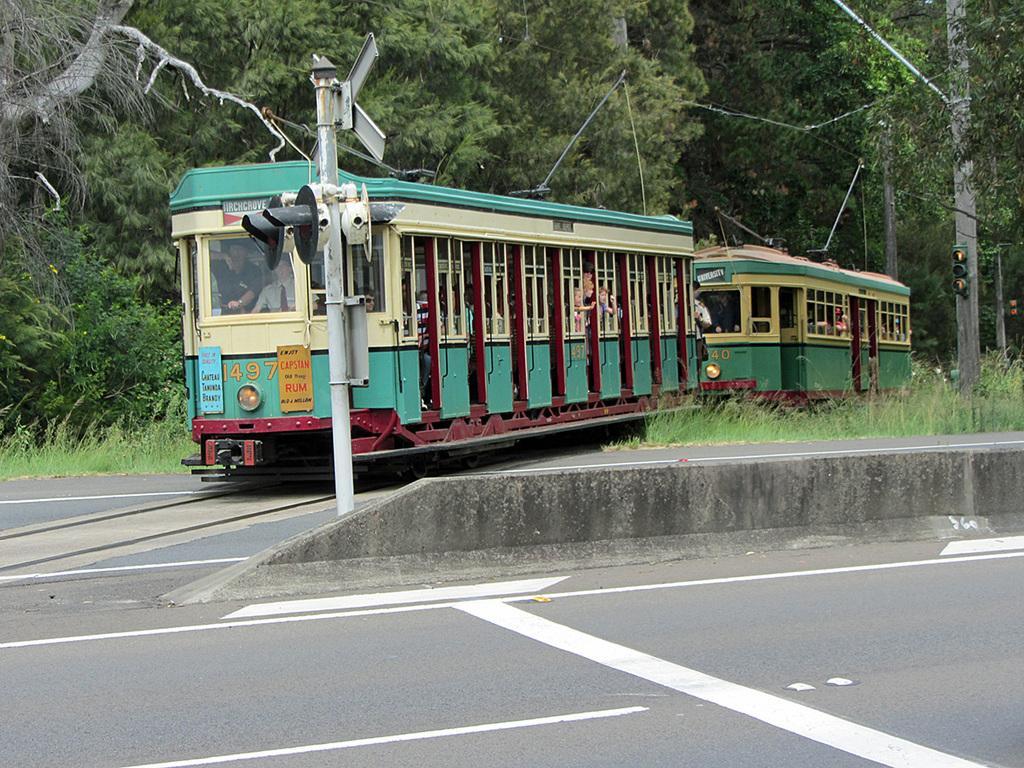Could you give a brief overview of what you see in this image? This is an outside view. In the middle of the image I can see the vehicles on the road. Inside the vehicles, I can see the people. Beside the road there are few poles. In the background there are many trees. On the right side, I can see the grass on the ground. 